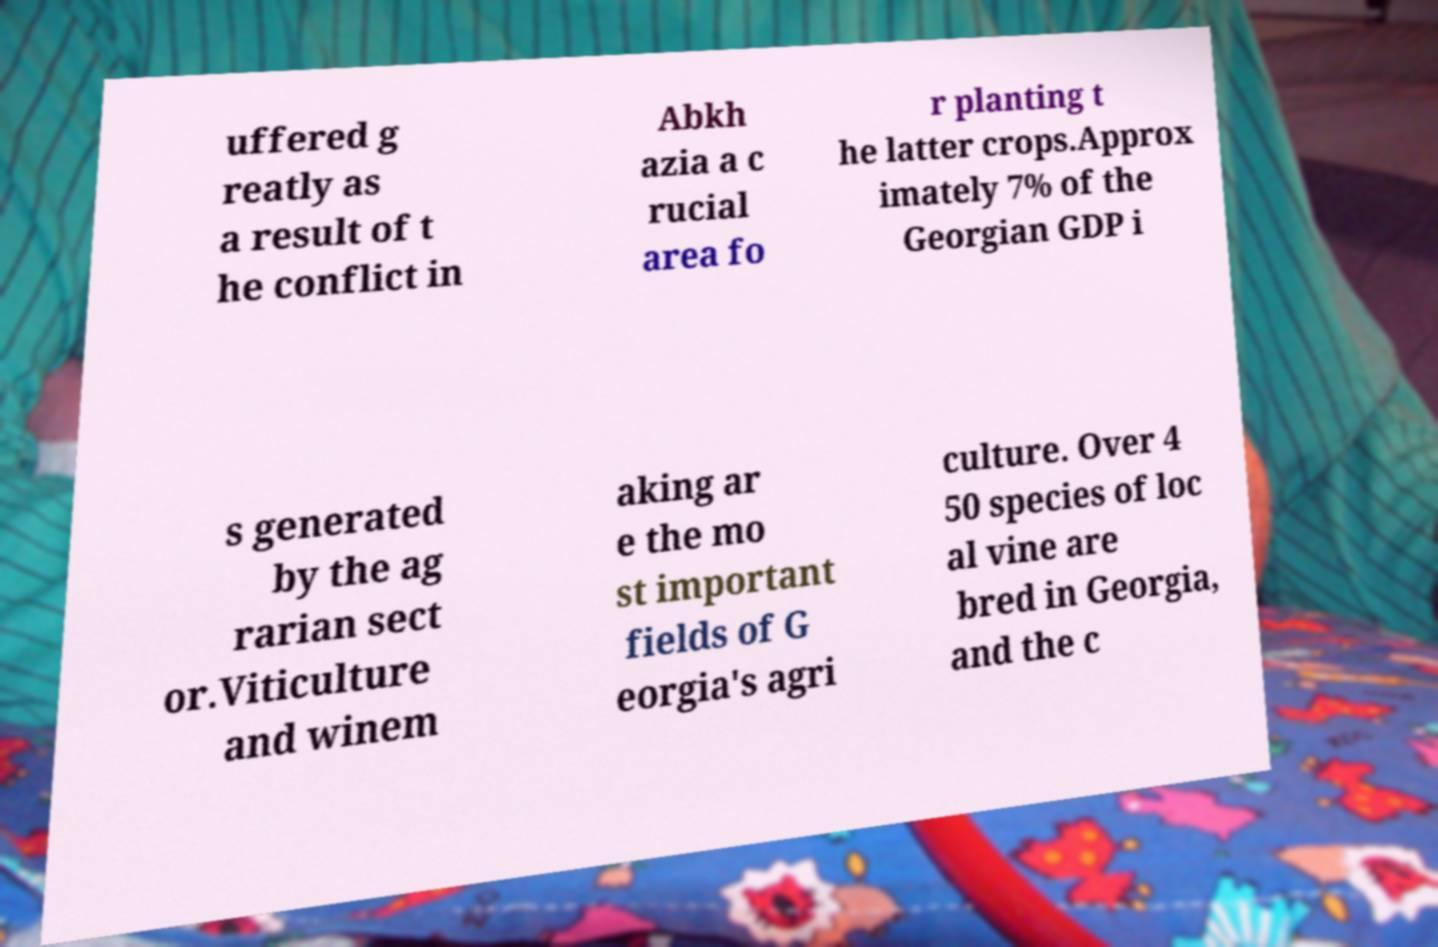Can you accurately transcribe the text from the provided image for me? uffered g reatly as a result of t he conflict in Abkh azia a c rucial area fo r planting t he latter crops.Approx imately 7% of the Georgian GDP i s generated by the ag rarian sect or.Viticulture and winem aking ar e the mo st important fields of G eorgia's agri culture. Over 4 50 species of loc al vine are bred in Georgia, and the c 